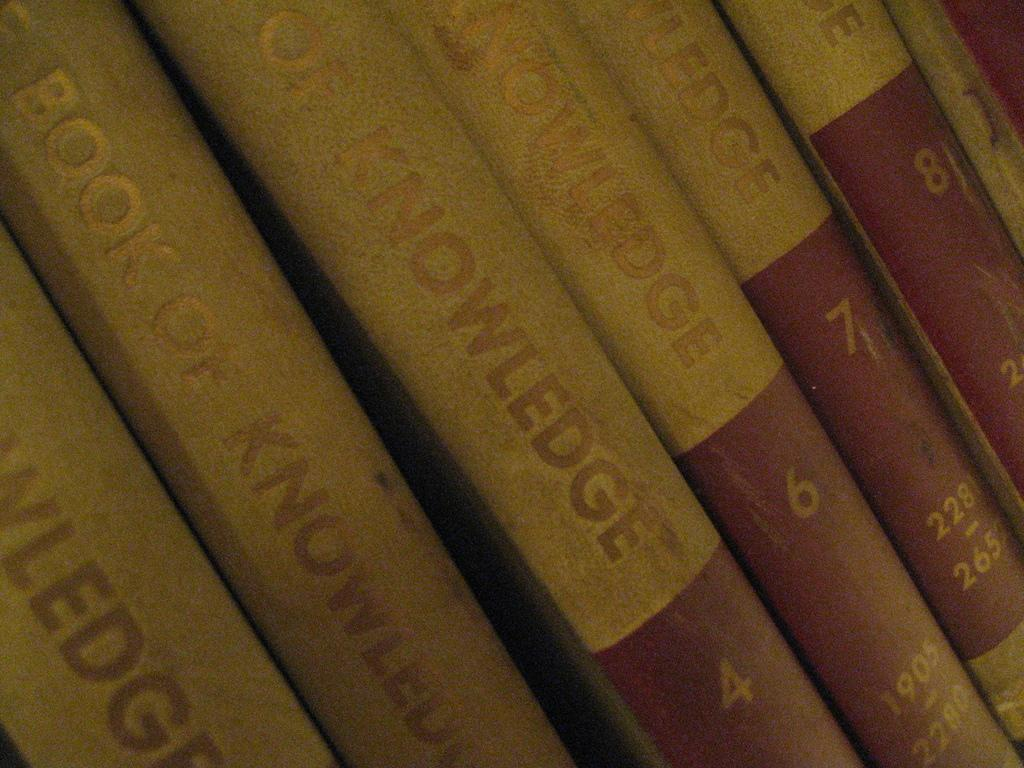<image>
Present a compact description of the photo's key features. six copies of the encyclopedia titled book of knowledge. 